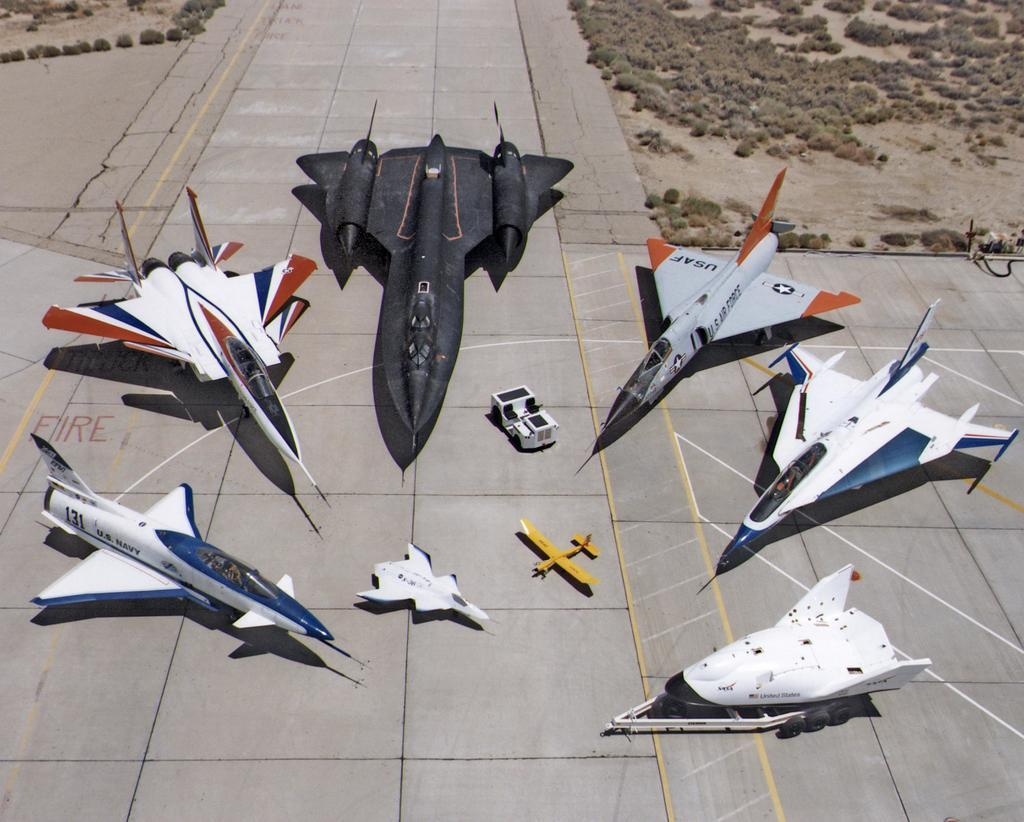What is the main subject in the center of the image? There are jet flights in the center of the image. What is located at the bottom of the image? There is a runway at the bottom of the image. What type of vegetation can be seen in the background of the image? There are bushes in the background of the image. What type of soda is being served at the airport in the image? There is no reference to soda or an airport in the image, so it is not possible to answer that question. 